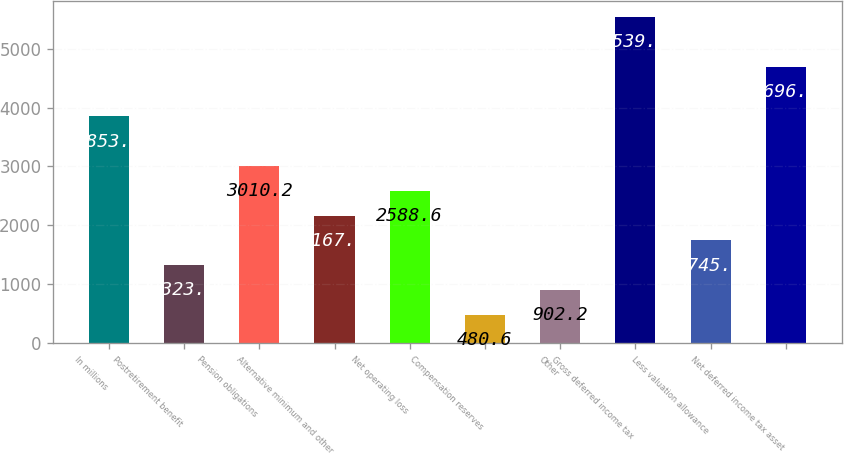Convert chart to OTSL. <chart><loc_0><loc_0><loc_500><loc_500><bar_chart><fcel>In millions<fcel>Postretirement benefit<fcel>Pension obligations<fcel>Alternative minimum and other<fcel>Net operating loss<fcel>Compensation reserves<fcel>Other<fcel>Gross deferred income tax<fcel>Less valuation allowance<fcel>Net deferred income tax asset<nl><fcel>3853.4<fcel>1323.8<fcel>3010.2<fcel>2167<fcel>2588.6<fcel>480.6<fcel>902.2<fcel>5539.8<fcel>1745.4<fcel>4696.6<nl></chart> 